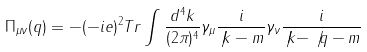<formula> <loc_0><loc_0><loc_500><loc_500>\Pi _ { \mu \nu } ( q ) = - ( - i e ) ^ { 2 } T r \int \frac { d ^ { 4 } k } { ( 2 \pi ) ^ { 4 } } \gamma _ { \mu } \frac { i } { \not { k } - m } \gamma _ { \nu } \frac { i } { \not { k } - \not { q } - m }</formula> 